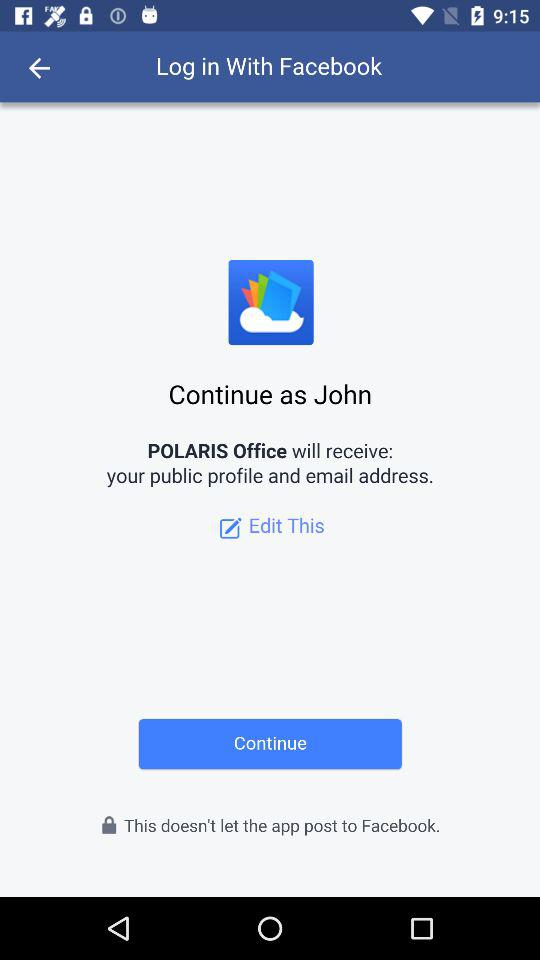What is the user name? The user name is John. 